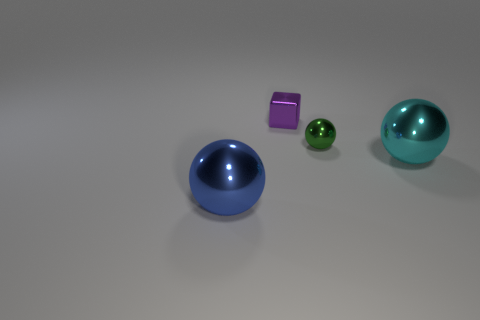What number of other small metal blocks are the same color as the tiny metal cube?
Provide a succinct answer. 0. Is the shape of the cyan metal thing the same as the blue shiny thing?
Provide a succinct answer. Yes. What is the size of the green metal object that is behind the metal sphere in front of the cyan thing?
Provide a succinct answer. Small. Is there a purple metal cube that has the same size as the green object?
Your response must be concise. Yes. Do the sphere on the left side of the tiny green metal object and the metallic sphere behind the large cyan metallic object have the same size?
Give a very brief answer. No. The big object left of the big thing to the right of the small purple object is what shape?
Make the answer very short. Sphere. What number of large blue shiny things are to the right of the tiny purple object?
Make the answer very short. 0. What color is the other tiny object that is made of the same material as the tiny purple object?
Your answer should be very brief. Green. There is a blue metallic sphere; is it the same size as the metal block that is behind the cyan metallic thing?
Keep it short and to the point. No. How big is the metallic sphere to the right of the tiny metallic object on the right side of the small thing to the left of the green object?
Provide a short and direct response. Large. 